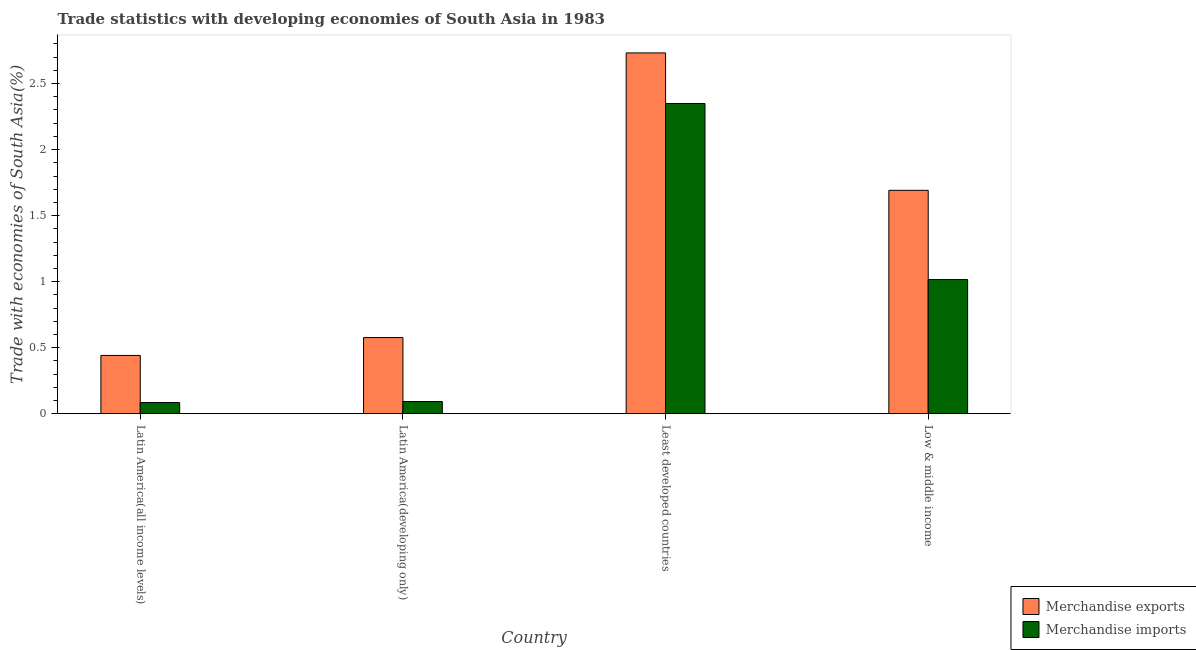How many different coloured bars are there?
Provide a short and direct response. 2. Are the number of bars per tick equal to the number of legend labels?
Ensure brevity in your answer.  Yes. How many bars are there on the 2nd tick from the right?
Offer a terse response. 2. What is the label of the 3rd group of bars from the left?
Your answer should be very brief. Least developed countries. What is the merchandise exports in Latin America(all income levels)?
Your response must be concise. 0.44. Across all countries, what is the maximum merchandise imports?
Provide a short and direct response. 2.35. Across all countries, what is the minimum merchandise exports?
Offer a terse response. 0.44. In which country was the merchandise imports maximum?
Your answer should be compact. Least developed countries. In which country was the merchandise imports minimum?
Keep it short and to the point. Latin America(all income levels). What is the total merchandise imports in the graph?
Offer a terse response. 3.54. What is the difference between the merchandise imports in Latin America(all income levels) and that in Least developed countries?
Provide a succinct answer. -2.26. What is the difference between the merchandise exports in Latin America(developing only) and the merchandise imports in Least developed countries?
Give a very brief answer. -1.77. What is the average merchandise exports per country?
Keep it short and to the point. 1.36. What is the difference between the merchandise exports and merchandise imports in Least developed countries?
Ensure brevity in your answer.  0.38. In how many countries, is the merchandise imports greater than 1.9 %?
Make the answer very short. 1. What is the ratio of the merchandise exports in Least developed countries to that in Low & middle income?
Offer a very short reply. 1.62. Is the difference between the merchandise exports in Latin America(all income levels) and Least developed countries greater than the difference between the merchandise imports in Latin America(all income levels) and Least developed countries?
Provide a succinct answer. No. What is the difference between the highest and the second highest merchandise exports?
Make the answer very short. 1.04. What is the difference between the highest and the lowest merchandise imports?
Your response must be concise. 2.26. In how many countries, is the merchandise imports greater than the average merchandise imports taken over all countries?
Make the answer very short. 2. What does the 1st bar from the right in Latin America(all income levels) represents?
Ensure brevity in your answer.  Merchandise imports. How many countries are there in the graph?
Make the answer very short. 4. Does the graph contain grids?
Offer a terse response. No. Where does the legend appear in the graph?
Ensure brevity in your answer.  Bottom right. How many legend labels are there?
Give a very brief answer. 2. What is the title of the graph?
Offer a terse response. Trade statistics with developing economies of South Asia in 1983. Does "National Visitors" appear as one of the legend labels in the graph?
Ensure brevity in your answer.  No. What is the label or title of the X-axis?
Your answer should be very brief. Country. What is the label or title of the Y-axis?
Provide a succinct answer. Trade with economies of South Asia(%). What is the Trade with economies of South Asia(%) of Merchandise exports in Latin America(all income levels)?
Your answer should be compact. 0.44. What is the Trade with economies of South Asia(%) in Merchandise imports in Latin America(all income levels)?
Provide a succinct answer. 0.08. What is the Trade with economies of South Asia(%) in Merchandise exports in Latin America(developing only)?
Provide a short and direct response. 0.58. What is the Trade with economies of South Asia(%) in Merchandise imports in Latin America(developing only)?
Your response must be concise. 0.09. What is the Trade with economies of South Asia(%) in Merchandise exports in Least developed countries?
Provide a short and direct response. 2.73. What is the Trade with economies of South Asia(%) of Merchandise imports in Least developed countries?
Provide a short and direct response. 2.35. What is the Trade with economies of South Asia(%) of Merchandise exports in Low & middle income?
Provide a succinct answer. 1.69. What is the Trade with economies of South Asia(%) of Merchandise imports in Low & middle income?
Ensure brevity in your answer.  1.02. Across all countries, what is the maximum Trade with economies of South Asia(%) of Merchandise exports?
Ensure brevity in your answer.  2.73. Across all countries, what is the maximum Trade with economies of South Asia(%) in Merchandise imports?
Make the answer very short. 2.35. Across all countries, what is the minimum Trade with economies of South Asia(%) in Merchandise exports?
Provide a succinct answer. 0.44. Across all countries, what is the minimum Trade with economies of South Asia(%) of Merchandise imports?
Your answer should be very brief. 0.08. What is the total Trade with economies of South Asia(%) of Merchandise exports in the graph?
Provide a succinct answer. 5.44. What is the total Trade with economies of South Asia(%) of Merchandise imports in the graph?
Provide a short and direct response. 3.54. What is the difference between the Trade with economies of South Asia(%) of Merchandise exports in Latin America(all income levels) and that in Latin America(developing only)?
Your answer should be very brief. -0.14. What is the difference between the Trade with economies of South Asia(%) in Merchandise imports in Latin America(all income levels) and that in Latin America(developing only)?
Offer a very short reply. -0.01. What is the difference between the Trade with economies of South Asia(%) in Merchandise exports in Latin America(all income levels) and that in Least developed countries?
Offer a terse response. -2.29. What is the difference between the Trade with economies of South Asia(%) of Merchandise imports in Latin America(all income levels) and that in Least developed countries?
Provide a succinct answer. -2.26. What is the difference between the Trade with economies of South Asia(%) in Merchandise exports in Latin America(all income levels) and that in Low & middle income?
Keep it short and to the point. -1.25. What is the difference between the Trade with economies of South Asia(%) of Merchandise imports in Latin America(all income levels) and that in Low & middle income?
Provide a short and direct response. -0.93. What is the difference between the Trade with economies of South Asia(%) in Merchandise exports in Latin America(developing only) and that in Least developed countries?
Make the answer very short. -2.16. What is the difference between the Trade with economies of South Asia(%) in Merchandise imports in Latin America(developing only) and that in Least developed countries?
Provide a succinct answer. -2.26. What is the difference between the Trade with economies of South Asia(%) of Merchandise exports in Latin America(developing only) and that in Low & middle income?
Your answer should be very brief. -1.11. What is the difference between the Trade with economies of South Asia(%) of Merchandise imports in Latin America(developing only) and that in Low & middle income?
Keep it short and to the point. -0.92. What is the difference between the Trade with economies of South Asia(%) of Merchandise exports in Least developed countries and that in Low & middle income?
Provide a short and direct response. 1.04. What is the difference between the Trade with economies of South Asia(%) of Merchandise imports in Least developed countries and that in Low & middle income?
Ensure brevity in your answer.  1.33. What is the difference between the Trade with economies of South Asia(%) of Merchandise exports in Latin America(all income levels) and the Trade with economies of South Asia(%) of Merchandise imports in Latin America(developing only)?
Your answer should be compact. 0.35. What is the difference between the Trade with economies of South Asia(%) of Merchandise exports in Latin America(all income levels) and the Trade with economies of South Asia(%) of Merchandise imports in Least developed countries?
Provide a succinct answer. -1.91. What is the difference between the Trade with economies of South Asia(%) in Merchandise exports in Latin America(all income levels) and the Trade with economies of South Asia(%) in Merchandise imports in Low & middle income?
Give a very brief answer. -0.57. What is the difference between the Trade with economies of South Asia(%) of Merchandise exports in Latin America(developing only) and the Trade with economies of South Asia(%) of Merchandise imports in Least developed countries?
Ensure brevity in your answer.  -1.77. What is the difference between the Trade with economies of South Asia(%) of Merchandise exports in Latin America(developing only) and the Trade with economies of South Asia(%) of Merchandise imports in Low & middle income?
Your response must be concise. -0.44. What is the difference between the Trade with economies of South Asia(%) in Merchandise exports in Least developed countries and the Trade with economies of South Asia(%) in Merchandise imports in Low & middle income?
Ensure brevity in your answer.  1.72. What is the average Trade with economies of South Asia(%) of Merchandise exports per country?
Offer a terse response. 1.36. What is the average Trade with economies of South Asia(%) of Merchandise imports per country?
Provide a short and direct response. 0.89. What is the difference between the Trade with economies of South Asia(%) of Merchandise exports and Trade with economies of South Asia(%) of Merchandise imports in Latin America(all income levels)?
Your response must be concise. 0.36. What is the difference between the Trade with economies of South Asia(%) in Merchandise exports and Trade with economies of South Asia(%) in Merchandise imports in Latin America(developing only)?
Ensure brevity in your answer.  0.48. What is the difference between the Trade with economies of South Asia(%) of Merchandise exports and Trade with economies of South Asia(%) of Merchandise imports in Least developed countries?
Provide a short and direct response. 0.38. What is the difference between the Trade with economies of South Asia(%) in Merchandise exports and Trade with economies of South Asia(%) in Merchandise imports in Low & middle income?
Offer a terse response. 0.68. What is the ratio of the Trade with economies of South Asia(%) of Merchandise exports in Latin America(all income levels) to that in Latin America(developing only)?
Provide a succinct answer. 0.77. What is the ratio of the Trade with economies of South Asia(%) in Merchandise imports in Latin America(all income levels) to that in Latin America(developing only)?
Ensure brevity in your answer.  0.92. What is the ratio of the Trade with economies of South Asia(%) of Merchandise exports in Latin America(all income levels) to that in Least developed countries?
Offer a very short reply. 0.16. What is the ratio of the Trade with economies of South Asia(%) of Merchandise imports in Latin America(all income levels) to that in Least developed countries?
Provide a short and direct response. 0.04. What is the ratio of the Trade with economies of South Asia(%) of Merchandise exports in Latin America(all income levels) to that in Low & middle income?
Your answer should be compact. 0.26. What is the ratio of the Trade with economies of South Asia(%) in Merchandise imports in Latin America(all income levels) to that in Low & middle income?
Give a very brief answer. 0.08. What is the ratio of the Trade with economies of South Asia(%) in Merchandise exports in Latin America(developing only) to that in Least developed countries?
Your answer should be compact. 0.21. What is the ratio of the Trade with economies of South Asia(%) in Merchandise imports in Latin America(developing only) to that in Least developed countries?
Your response must be concise. 0.04. What is the ratio of the Trade with economies of South Asia(%) in Merchandise exports in Latin America(developing only) to that in Low & middle income?
Keep it short and to the point. 0.34. What is the ratio of the Trade with economies of South Asia(%) in Merchandise imports in Latin America(developing only) to that in Low & middle income?
Your response must be concise. 0.09. What is the ratio of the Trade with economies of South Asia(%) of Merchandise exports in Least developed countries to that in Low & middle income?
Provide a short and direct response. 1.61. What is the ratio of the Trade with economies of South Asia(%) in Merchandise imports in Least developed countries to that in Low & middle income?
Keep it short and to the point. 2.31. What is the difference between the highest and the second highest Trade with economies of South Asia(%) of Merchandise exports?
Your answer should be compact. 1.04. What is the difference between the highest and the second highest Trade with economies of South Asia(%) in Merchandise imports?
Keep it short and to the point. 1.33. What is the difference between the highest and the lowest Trade with economies of South Asia(%) of Merchandise exports?
Ensure brevity in your answer.  2.29. What is the difference between the highest and the lowest Trade with economies of South Asia(%) of Merchandise imports?
Ensure brevity in your answer.  2.26. 